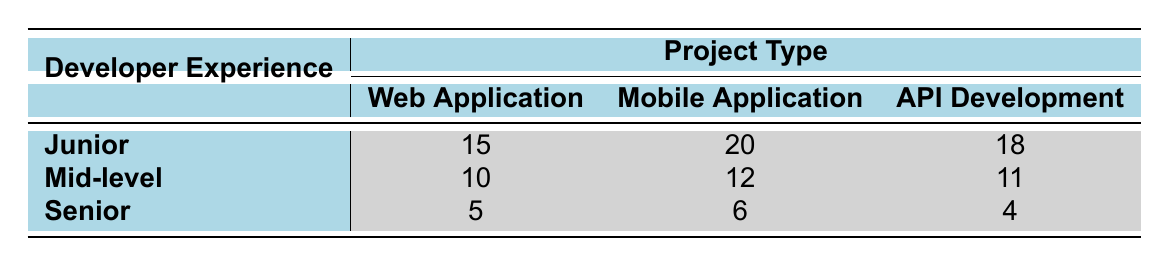What is the average bug resolution time for Junior developers in API Development? The average bug resolution time for Junior developers in API Development is 18 hours, as per the values in the table.
Answer: 18 hours What is the bug resolution time difference between Senior and Junior developers in Mobile Application projects? The bug resolution time for Senior developers in Mobile Application projects is 6 hours, while for Junior developers, it is 20 hours. The difference is 20 - 6 = 14 hours.
Answer: 14 hours Is the average bug resolution time for Mid-level developers better than that for Junior developers in Web Application projects? For Web Application projects, average bug resolution time for Mid-level developers is 10 hours and for Junior developers is 15 hours. Since 10 is less than 15, it indicates that Mid-level developers have a better resolution time.
Answer: Yes What is the total average bug resolution time for Senior developers across all project types? The average bug resolution time for Senior developers is 5 hours for Web Applications, 6 hours for Mobile Applications, and 4 hours for API Development. The total is 5 + 6 + 4 = 15 hours.
Answer: 15 hours Which project type has the longest average bug resolution time for Junior developers? The average bug resolution times for Junior developers are 15 hours for Web Applications, 20 hours for Mobile Applications, and 18 hours for API Development. Mobile Application has the longest time, which is 20 hours.
Answer: Mobile Application How much shorter is the bug resolution time for Senior developers compared to Mid-level developers in API Development projects? The average bug resolution time for Senior developers in API Development is 4 hours, while for Mid-level developers, it is 11 hours. The difference is 11 - 4 = 7 hours shorter for Senior developers.
Answer: 7 hours Do Mid-level developers take longer to resolve bugs in Web Applications compared to Senior developers? The average bug resolution time for Mid-level developers in Web Applications is 10 hours, while for Senior developers, it is 5 hours. Since 10 is greater than 5, Mid-level developers take longer.
Answer: Yes What is the average bug resolution time for all Developer Experience Levels combined in Mobile Application projects? The average bug resolution times for Mobile Applications are: Junior 20 hours, Mid-level 12 hours, and Senior 6 hours. The sum is (20 + 12 + 6) = 38 hours, and there are 3 levels, so the average is 38/3 = approximately 12.67 hours.
Answer: 12.67 hours 